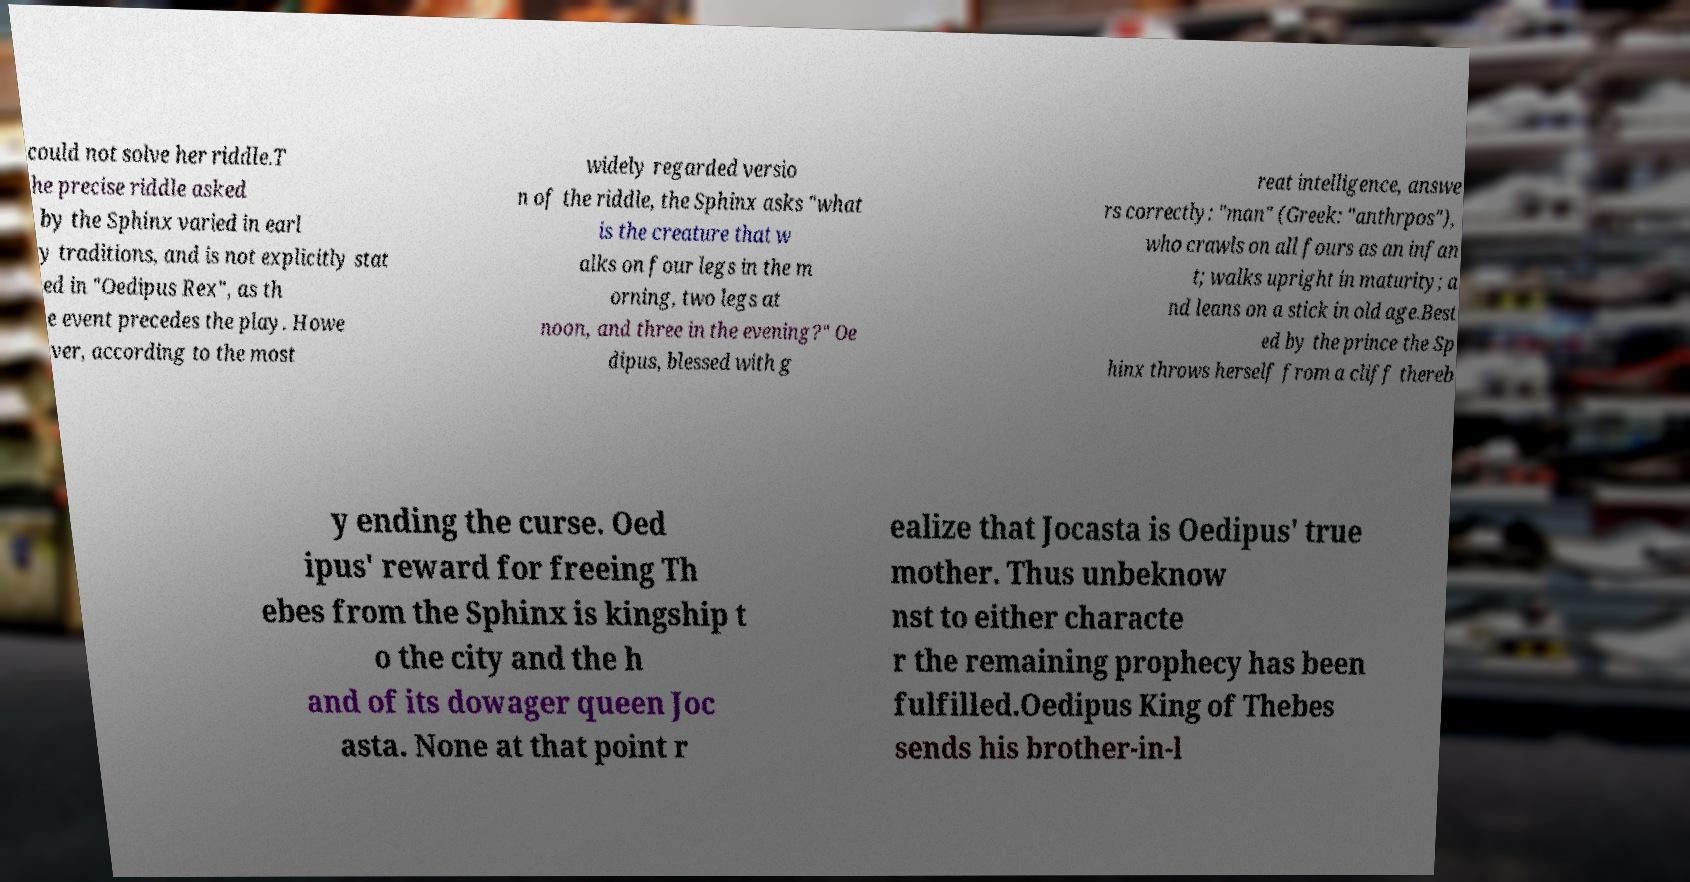Please identify and transcribe the text found in this image. could not solve her riddle.T he precise riddle asked by the Sphinx varied in earl y traditions, and is not explicitly stat ed in "Oedipus Rex", as th e event precedes the play. Howe ver, according to the most widely regarded versio n of the riddle, the Sphinx asks "what is the creature that w alks on four legs in the m orning, two legs at noon, and three in the evening?" Oe dipus, blessed with g reat intelligence, answe rs correctly: "man" (Greek: "anthrpos"), who crawls on all fours as an infan t; walks upright in maturity; a nd leans on a stick in old age.Best ed by the prince the Sp hinx throws herself from a cliff thereb y ending the curse. Oed ipus' reward for freeing Th ebes from the Sphinx is kingship t o the city and the h and of its dowager queen Joc asta. None at that point r ealize that Jocasta is Oedipus' true mother. Thus unbeknow nst to either characte r the remaining prophecy has been fulfilled.Oedipus King of Thebes sends his brother-in-l 